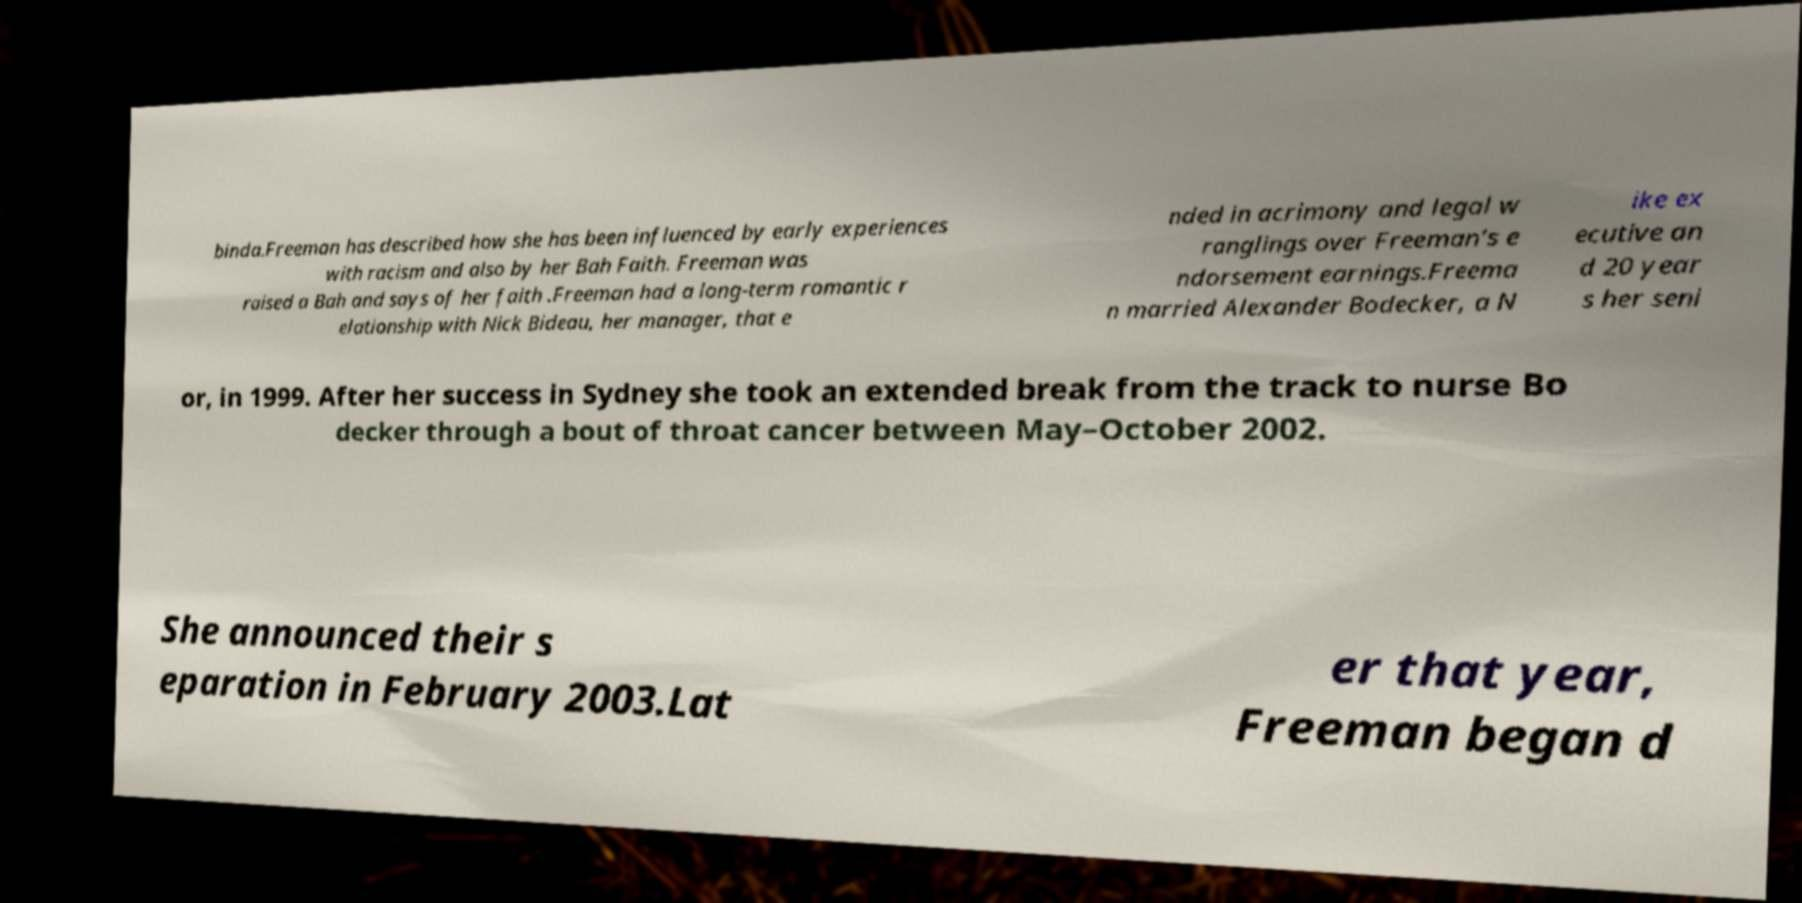I need the written content from this picture converted into text. Can you do that? binda.Freeman has described how she has been influenced by early experiences with racism and also by her Bah Faith. Freeman was raised a Bah and says of her faith .Freeman had a long-term romantic r elationship with Nick Bideau, her manager, that e nded in acrimony and legal w ranglings over Freeman's e ndorsement earnings.Freema n married Alexander Bodecker, a N ike ex ecutive an d 20 year s her seni or, in 1999. After her success in Sydney she took an extended break from the track to nurse Bo decker through a bout of throat cancer between May–October 2002. She announced their s eparation in February 2003.Lat er that year, Freeman began d 